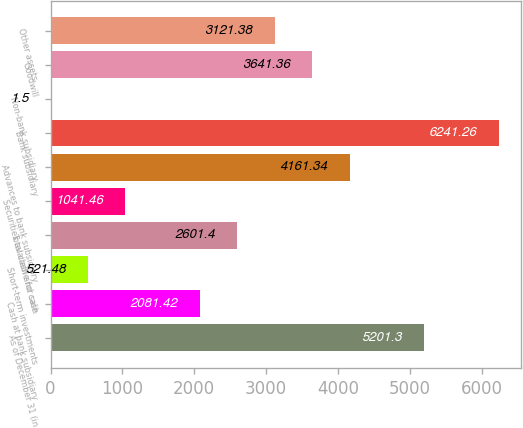<chart> <loc_0><loc_0><loc_500><loc_500><bar_chart><fcel>As of December 31 (in<fcel>Cash at bank subsidiary<fcel>Short-term investments<fcel>Total cash and cash<fcel>Securities available for sale<fcel>Advances to bank subsidiary<fcel>Bank subsidiary<fcel>Non-bank subsidiary<fcel>Goodwill<fcel>Other assets<nl><fcel>5201.3<fcel>2081.42<fcel>521.48<fcel>2601.4<fcel>1041.46<fcel>4161.34<fcel>6241.26<fcel>1.5<fcel>3641.36<fcel>3121.38<nl></chart> 